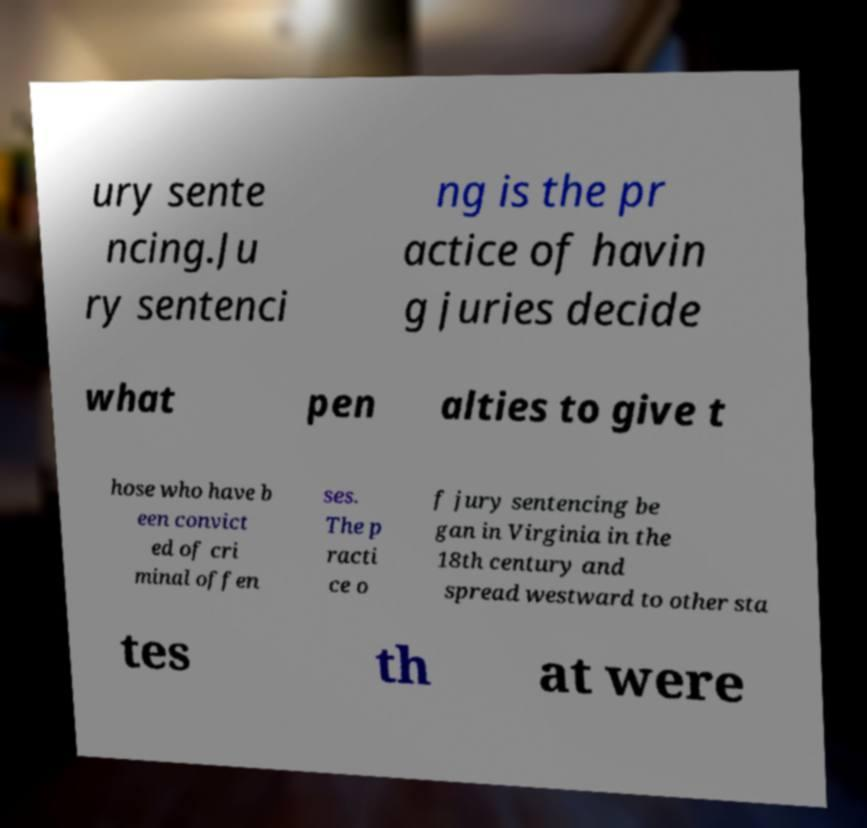Can you accurately transcribe the text from the provided image for me? ury sente ncing.Ju ry sentenci ng is the pr actice of havin g juries decide what pen alties to give t hose who have b een convict ed of cri minal offen ses. The p racti ce o f jury sentencing be gan in Virginia in the 18th century and spread westward to other sta tes th at were 